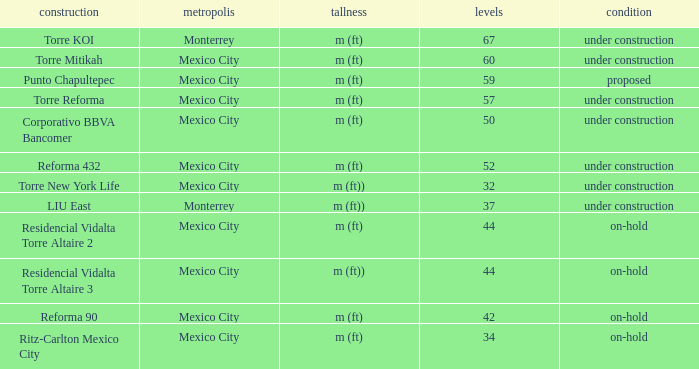What is the status of the torre reforma building that is over 44 stories in mexico city? Under construction. 